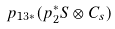Convert formula to latex. <formula><loc_0><loc_0><loc_500><loc_500>p _ { 1 3 * } ( p _ { 2 } ^ { * } S \otimes C _ { s } )</formula> 